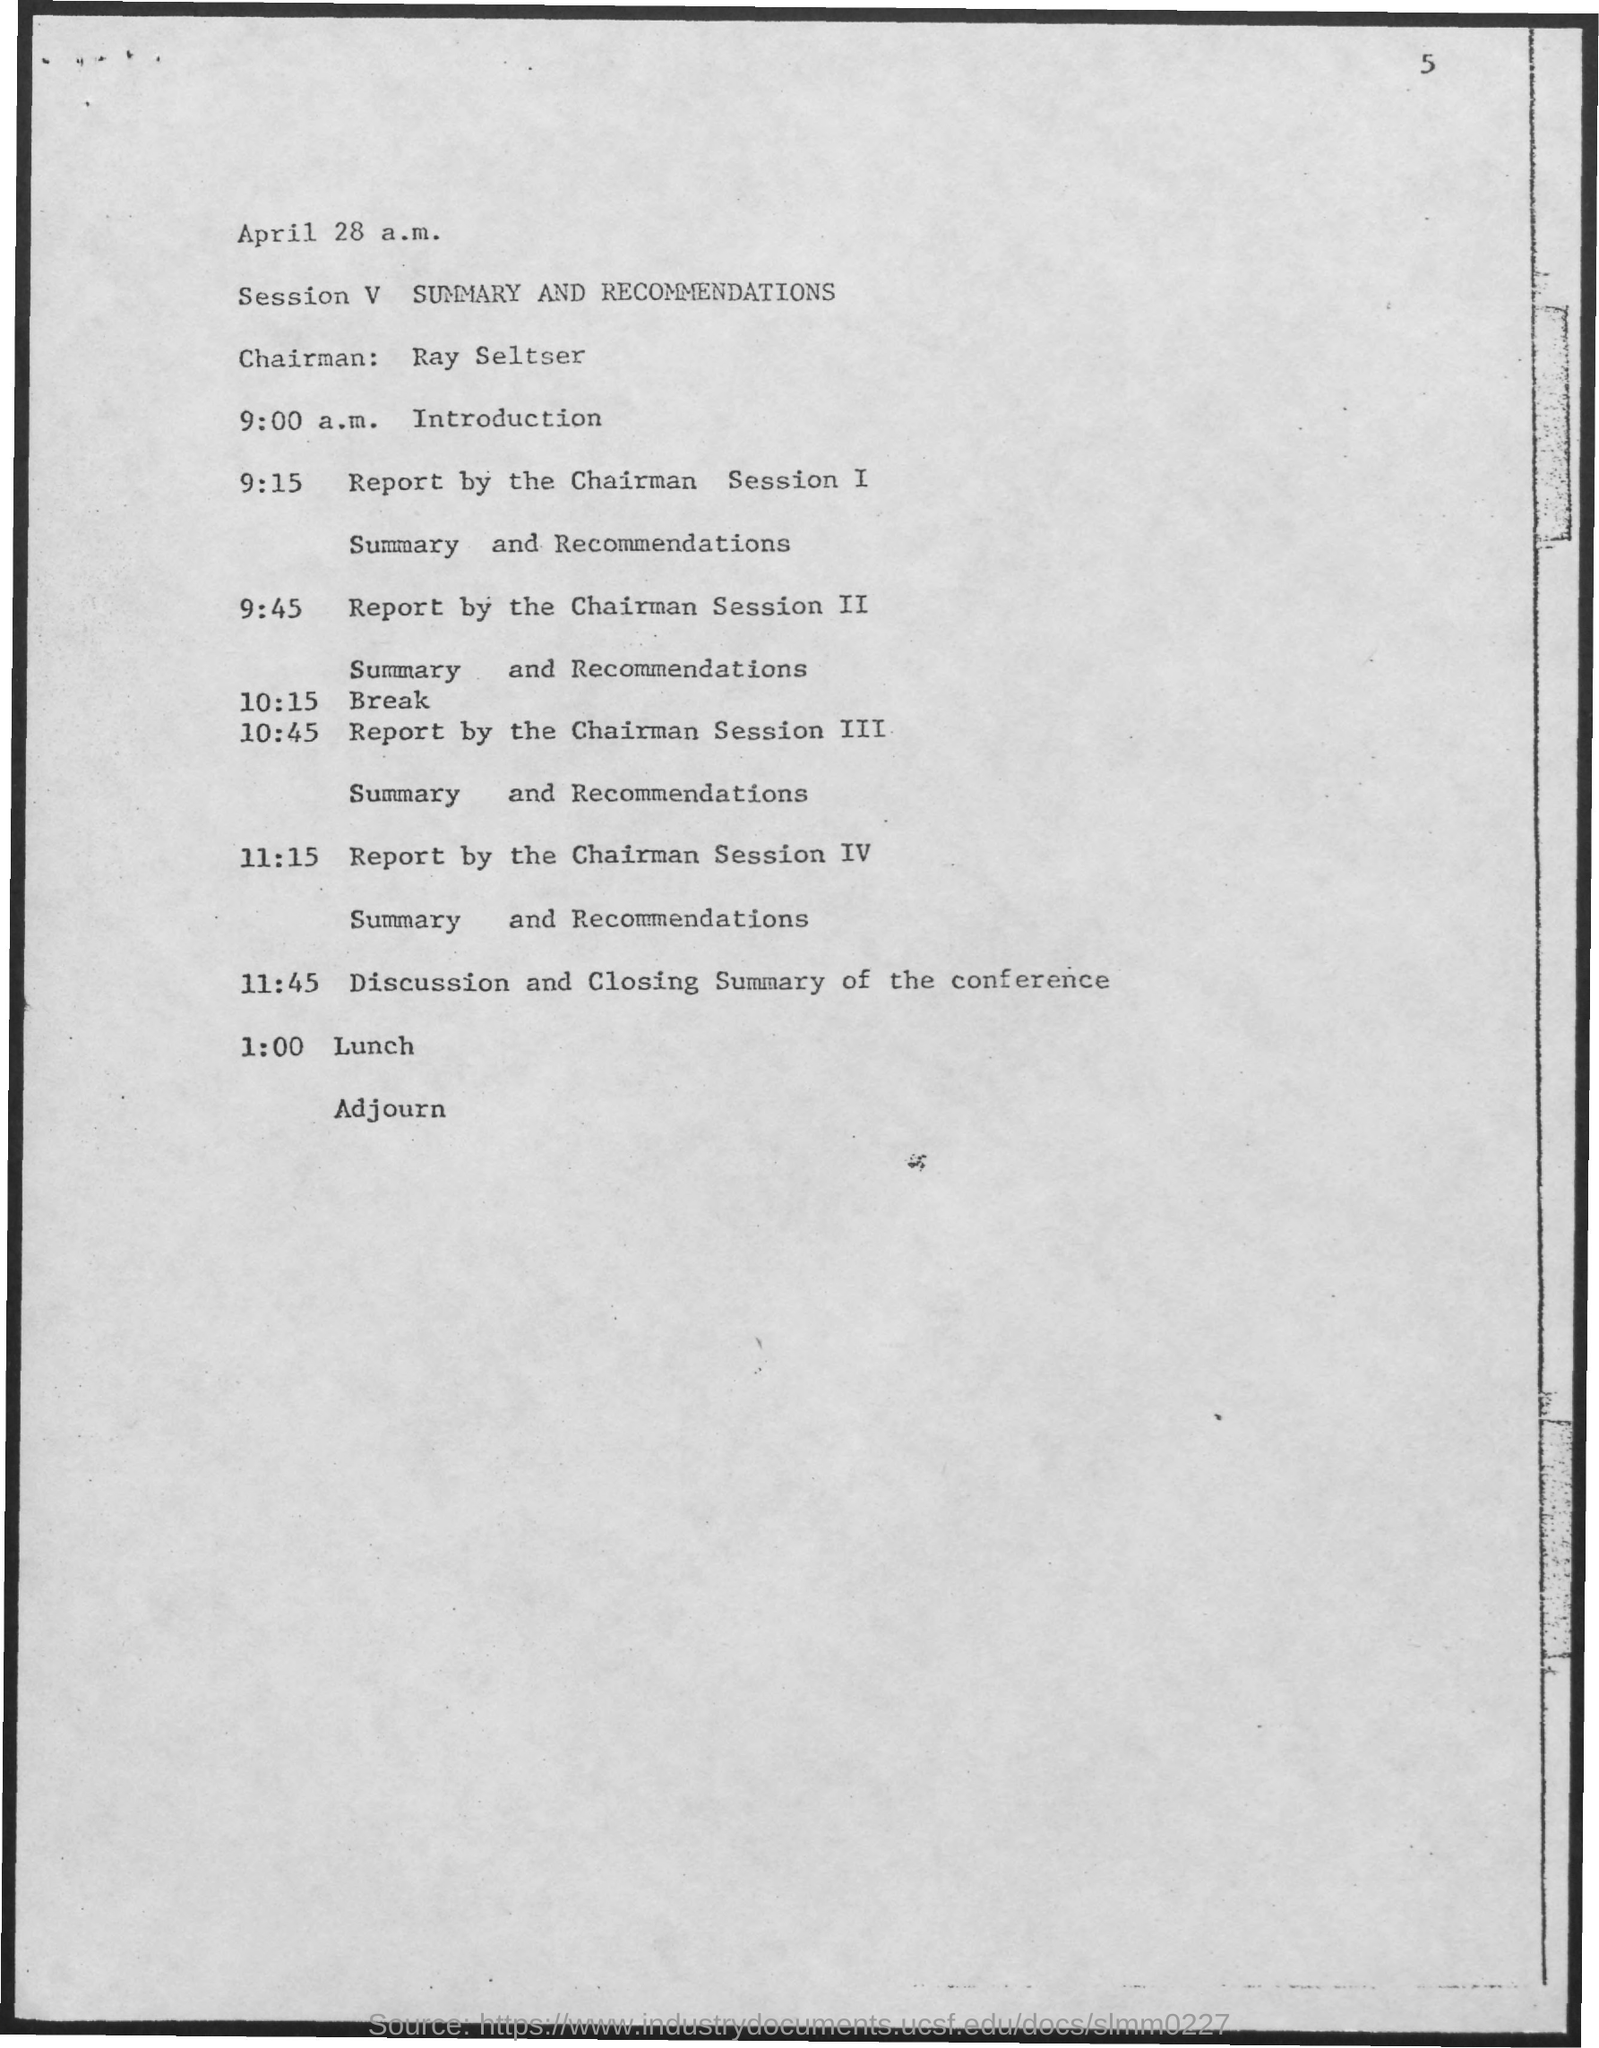Outline some significant characteristics in this image. Ray Seltser is the chairman. At 11:45, there will be a discussion and closing summary of the conference. During session V, the topic of discussion was a summary and recommendations. 